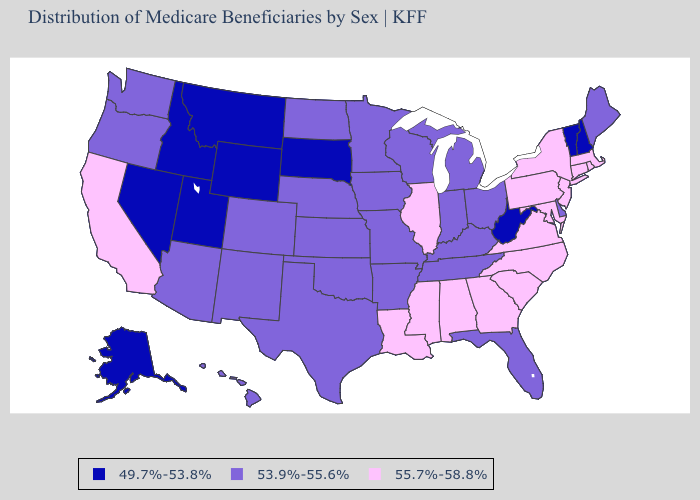What is the value of Wisconsin?
Keep it brief. 53.9%-55.6%. What is the highest value in the West ?
Quick response, please. 55.7%-58.8%. What is the value of Missouri?
Keep it brief. 53.9%-55.6%. Does New Jersey have the highest value in the USA?
Short answer required. Yes. Does the map have missing data?
Write a very short answer. No. What is the value of Alaska?
Give a very brief answer. 49.7%-53.8%. What is the value of Idaho?
Quick response, please. 49.7%-53.8%. What is the value of Louisiana?
Write a very short answer. 55.7%-58.8%. Does Maine have the lowest value in the Northeast?
Short answer required. No. Which states hav the highest value in the South?
Concise answer only. Alabama, Georgia, Louisiana, Maryland, Mississippi, North Carolina, South Carolina, Virginia. Does Tennessee have the highest value in the South?
Answer briefly. No. Among the states that border Missouri , does Kansas have the highest value?
Answer briefly. No. What is the lowest value in states that border Oregon?
Concise answer only. 49.7%-53.8%. What is the value of Georgia?
Short answer required. 55.7%-58.8%. Name the states that have a value in the range 49.7%-53.8%?
Concise answer only. Alaska, Idaho, Montana, Nevada, New Hampshire, South Dakota, Utah, Vermont, West Virginia, Wyoming. 